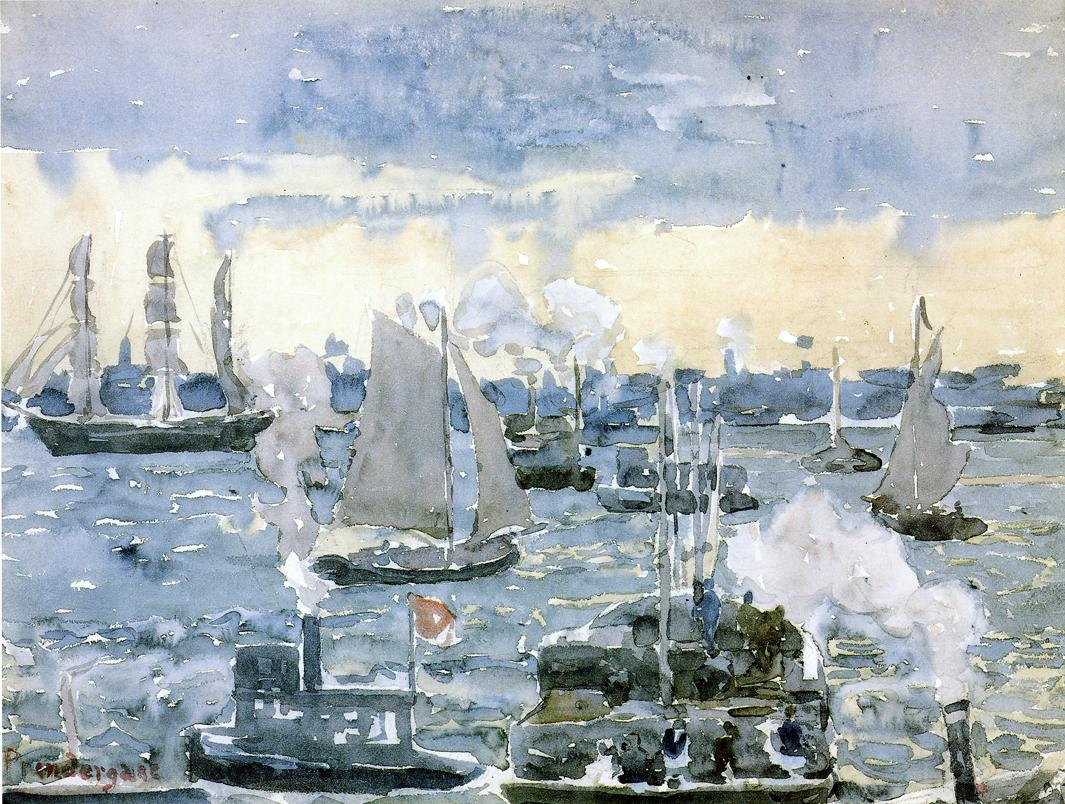What are the key elements in this picture? The key elements in this picture are characterized by an impressionist depiction of a lively harbor scene. The artist skillfully uses a loose and fluid style to emphasize the interplay of colors, particularly focusing on tones of blue, white, green, and brown. The scene is populated with various boats and ships, some with billowing sails indicating a windy day, and others with smokestacks, hinting at the era of the industrial revolution. The choppy waters mirror the cloudy sky, adding a dynamic sense of movement and energy to the composition, epitomizing the essence of impressionist art where the overall feel and perception take precedence over precise details. 